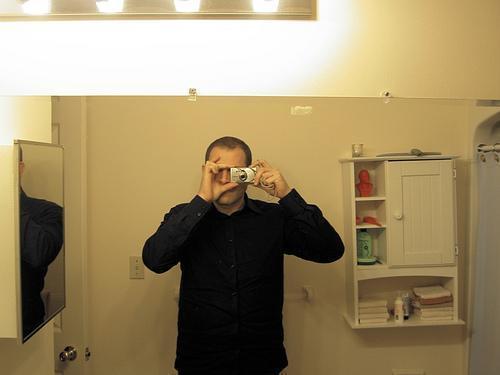What type of camera is he using?
Select the correct answer and articulate reasoning with the following format: 'Answer: answer
Rationale: rationale.'
Options: Film, dslr, phone, digital. Answer: digital.
Rationale: The camera is digital. 